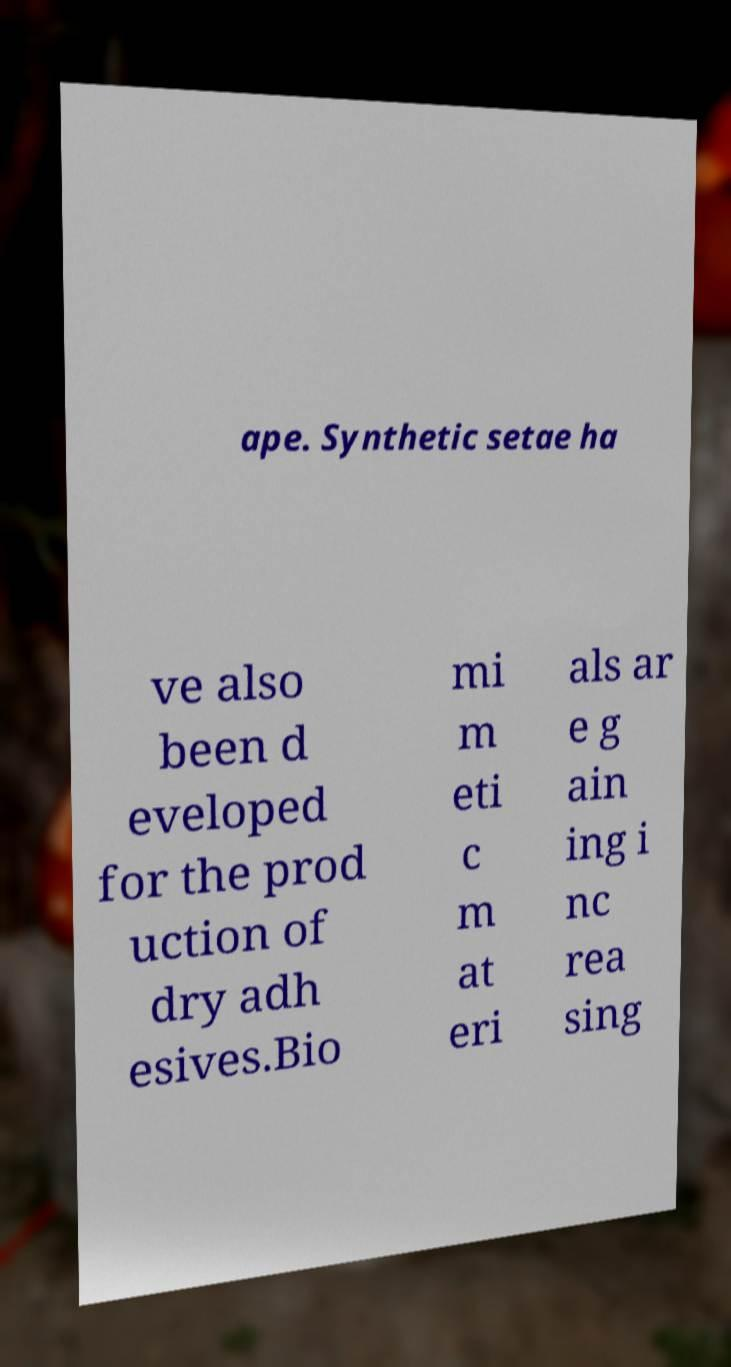For documentation purposes, I need the text within this image transcribed. Could you provide that? ape. Synthetic setae ha ve also been d eveloped for the prod uction of dry adh esives.Bio mi m eti c m at eri als ar e g ain ing i nc rea sing 